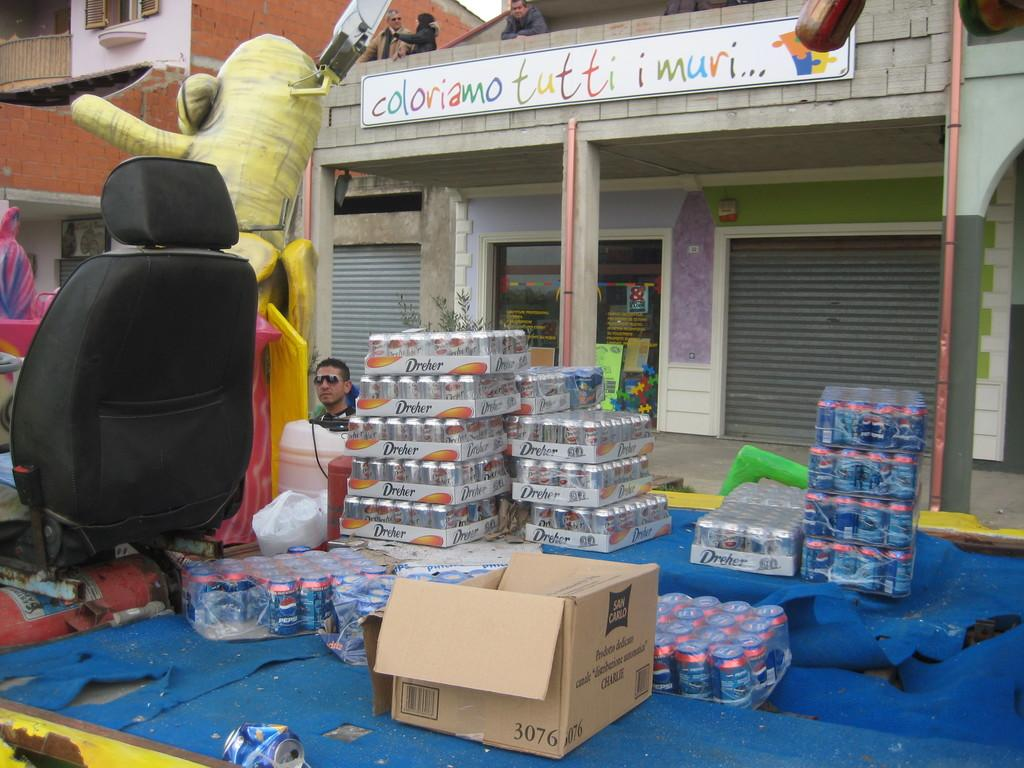<image>
Present a compact description of the photo's key features. Cartons of sodas, including Pepsi, sit on the back of a truck. 